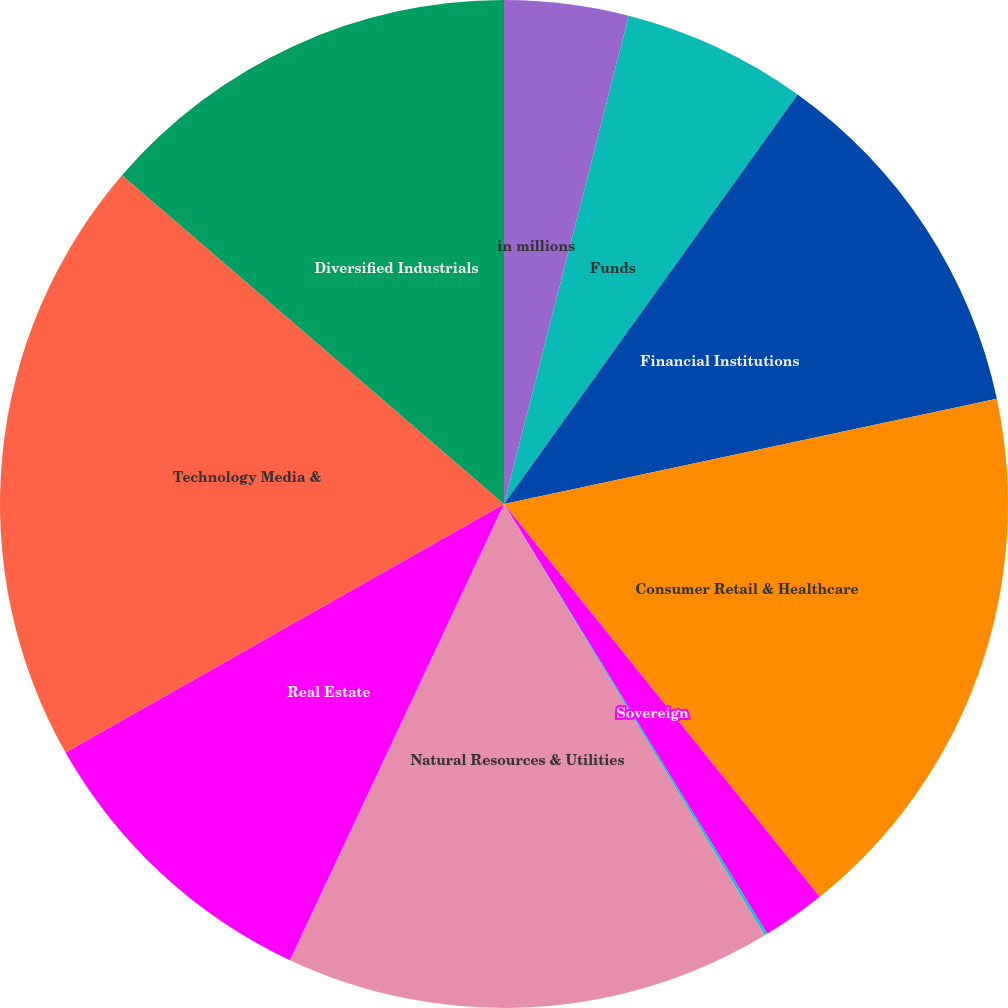Convert chart to OTSL. <chart><loc_0><loc_0><loc_500><loc_500><pie_chart><fcel>in millions<fcel>Funds<fcel>Financial Institutions<fcel>Consumer Retail & Healthcare<fcel>Sovereign<fcel>Municipalities & Nonprofit<fcel>Natural Resources & Utilities<fcel>Real Estate<fcel>Technology Media &<fcel>Diversified Industrials<nl><fcel>3.98%<fcel>5.92%<fcel>11.75%<fcel>17.58%<fcel>2.03%<fcel>0.09%<fcel>15.64%<fcel>9.81%<fcel>19.52%<fcel>13.69%<nl></chart> 